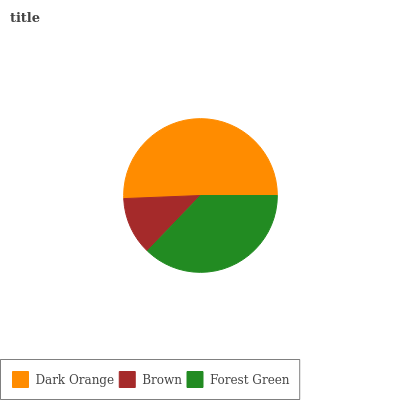Is Brown the minimum?
Answer yes or no. Yes. Is Dark Orange the maximum?
Answer yes or no. Yes. Is Forest Green the minimum?
Answer yes or no. No. Is Forest Green the maximum?
Answer yes or no. No. Is Forest Green greater than Brown?
Answer yes or no. Yes. Is Brown less than Forest Green?
Answer yes or no. Yes. Is Brown greater than Forest Green?
Answer yes or no. No. Is Forest Green less than Brown?
Answer yes or no. No. Is Forest Green the high median?
Answer yes or no. Yes. Is Forest Green the low median?
Answer yes or no. Yes. Is Brown the high median?
Answer yes or no. No. Is Dark Orange the low median?
Answer yes or no. No. 